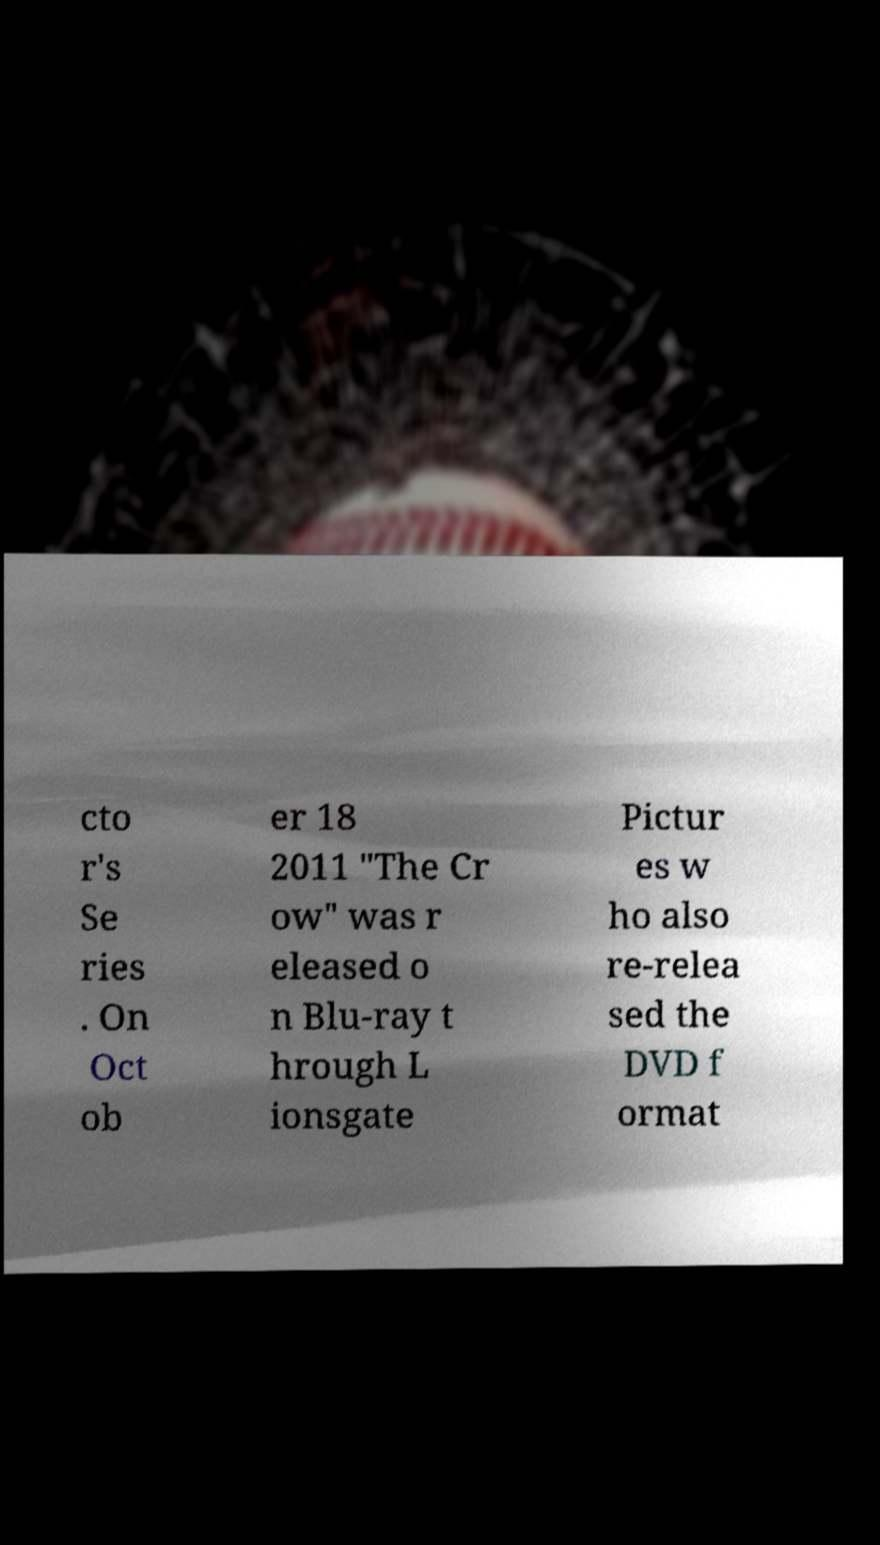For documentation purposes, I need the text within this image transcribed. Could you provide that? cto r's Se ries . On Oct ob er 18 2011 "The Cr ow" was r eleased o n Blu-ray t hrough L ionsgate Pictur es w ho also re-relea sed the DVD f ormat 